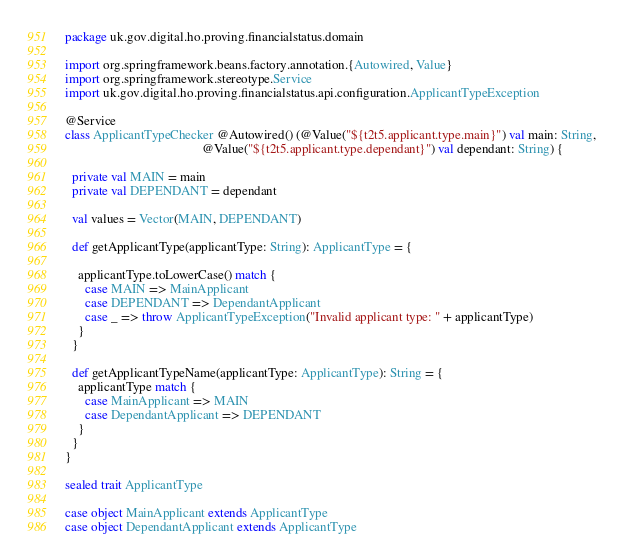Convert code to text. <code><loc_0><loc_0><loc_500><loc_500><_Scala_>package uk.gov.digital.ho.proving.financialstatus.domain

import org.springframework.beans.factory.annotation.{Autowired, Value}
import org.springframework.stereotype.Service
import uk.gov.digital.ho.proving.financialstatus.api.configuration.ApplicantTypeException

@Service
class ApplicantTypeChecker @Autowired() (@Value("${t2t5.applicant.type.main}") val main: String,
                                          @Value("${t2t5.applicant.type.dependant}") val dependant: String) {

  private val MAIN = main
  private val DEPENDANT = dependant

  val values = Vector(MAIN, DEPENDANT)

  def getApplicantType(applicantType: String): ApplicantType = {

    applicantType.toLowerCase() match {
      case MAIN => MainApplicant
      case DEPENDANT => DependantApplicant
      case _ => throw ApplicantTypeException("Invalid applicant type: " + applicantType)
    }
  }

  def getApplicantTypeName(applicantType: ApplicantType): String = {
    applicantType match {
      case MainApplicant => MAIN
      case DependantApplicant => DEPENDANT
    }
  }
}

sealed trait ApplicantType

case object MainApplicant extends ApplicantType
case object DependantApplicant extends ApplicantType
</code> 